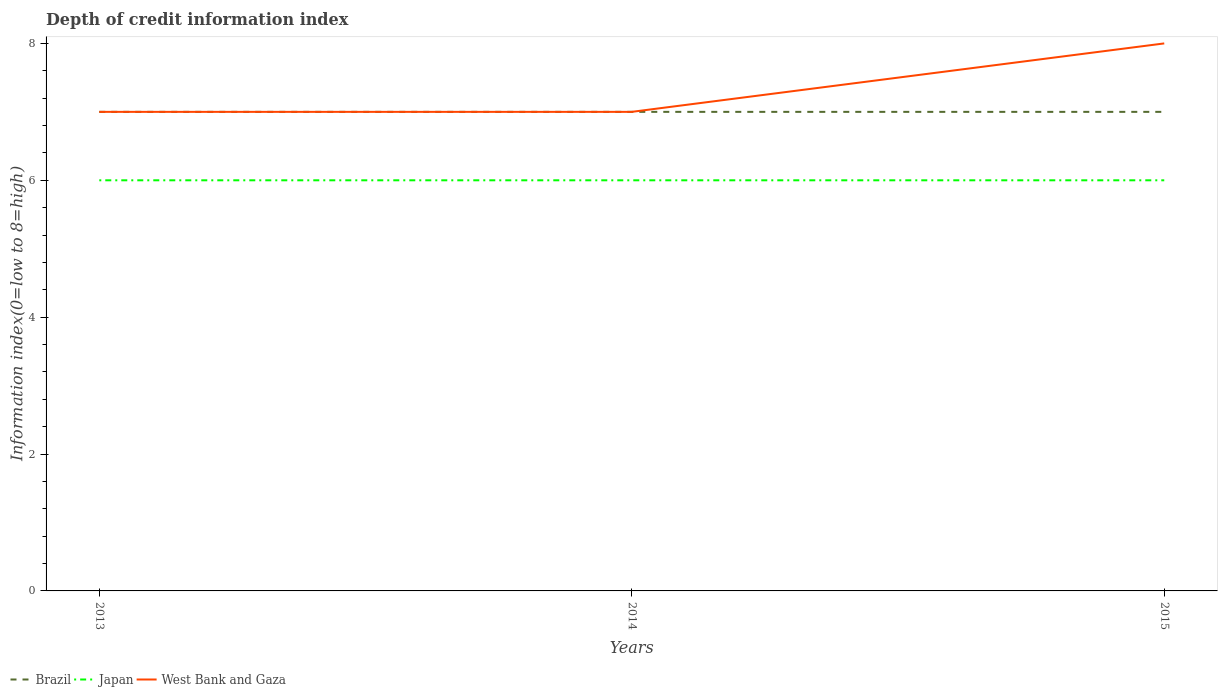How many different coloured lines are there?
Give a very brief answer. 3. Is the number of lines equal to the number of legend labels?
Offer a terse response. Yes. Across all years, what is the maximum information index in West Bank and Gaza?
Offer a very short reply. 7. What is the total information index in Brazil in the graph?
Your answer should be very brief. 0. What is the difference between the highest and the second highest information index in Brazil?
Give a very brief answer. 0. What is the difference between the highest and the lowest information index in Japan?
Your response must be concise. 0. How many lines are there?
Provide a succinct answer. 3. Does the graph contain any zero values?
Provide a succinct answer. No. Does the graph contain grids?
Keep it short and to the point. No. Where does the legend appear in the graph?
Your answer should be compact. Bottom left. How many legend labels are there?
Ensure brevity in your answer.  3. How are the legend labels stacked?
Offer a very short reply. Horizontal. What is the title of the graph?
Ensure brevity in your answer.  Depth of credit information index. What is the label or title of the X-axis?
Provide a short and direct response. Years. What is the label or title of the Y-axis?
Your answer should be compact. Information index(0=low to 8=high). What is the Information index(0=low to 8=high) of Japan in 2013?
Offer a terse response. 6. What is the Information index(0=low to 8=high) in West Bank and Gaza in 2013?
Ensure brevity in your answer.  7. What is the Information index(0=low to 8=high) of Brazil in 2014?
Provide a short and direct response. 7. What is the Information index(0=low to 8=high) in Japan in 2014?
Make the answer very short. 6. What is the Information index(0=low to 8=high) of West Bank and Gaza in 2014?
Your response must be concise. 7. What is the Information index(0=low to 8=high) in Japan in 2015?
Give a very brief answer. 6. What is the Information index(0=low to 8=high) in West Bank and Gaza in 2015?
Your answer should be very brief. 8. Across all years, what is the maximum Information index(0=low to 8=high) of Brazil?
Provide a short and direct response. 7. Across all years, what is the minimum Information index(0=low to 8=high) in Brazil?
Make the answer very short. 7. Across all years, what is the minimum Information index(0=low to 8=high) of Japan?
Make the answer very short. 6. What is the total Information index(0=low to 8=high) of Japan in the graph?
Your response must be concise. 18. What is the difference between the Information index(0=low to 8=high) of Brazil in 2013 and that in 2014?
Keep it short and to the point. 0. What is the difference between the Information index(0=low to 8=high) of Japan in 2013 and that in 2014?
Provide a succinct answer. 0. What is the difference between the Information index(0=low to 8=high) in West Bank and Gaza in 2013 and that in 2014?
Ensure brevity in your answer.  0. What is the difference between the Information index(0=low to 8=high) of West Bank and Gaza in 2014 and that in 2015?
Make the answer very short. -1. What is the difference between the Information index(0=low to 8=high) of Brazil in 2013 and the Information index(0=low to 8=high) of West Bank and Gaza in 2014?
Ensure brevity in your answer.  0. What is the difference between the Information index(0=low to 8=high) in Japan in 2013 and the Information index(0=low to 8=high) in West Bank and Gaza in 2015?
Give a very brief answer. -2. What is the average Information index(0=low to 8=high) of Brazil per year?
Offer a terse response. 7. What is the average Information index(0=low to 8=high) in Japan per year?
Ensure brevity in your answer.  6. What is the average Information index(0=low to 8=high) in West Bank and Gaza per year?
Make the answer very short. 7.33. In the year 2013, what is the difference between the Information index(0=low to 8=high) of Brazil and Information index(0=low to 8=high) of Japan?
Ensure brevity in your answer.  1. In the year 2013, what is the difference between the Information index(0=low to 8=high) in Brazil and Information index(0=low to 8=high) in West Bank and Gaza?
Your response must be concise. 0. In the year 2013, what is the difference between the Information index(0=low to 8=high) in Japan and Information index(0=low to 8=high) in West Bank and Gaza?
Give a very brief answer. -1. In the year 2014, what is the difference between the Information index(0=low to 8=high) of Brazil and Information index(0=low to 8=high) of West Bank and Gaza?
Provide a succinct answer. 0. What is the ratio of the Information index(0=low to 8=high) in Brazil in 2013 to that in 2014?
Your answer should be compact. 1. What is the ratio of the Information index(0=low to 8=high) in Japan in 2013 to that in 2014?
Make the answer very short. 1. What is the ratio of the Information index(0=low to 8=high) of Japan in 2013 to that in 2015?
Provide a succinct answer. 1. What is the ratio of the Information index(0=low to 8=high) in Brazil in 2014 to that in 2015?
Provide a succinct answer. 1. What is the ratio of the Information index(0=low to 8=high) in Japan in 2014 to that in 2015?
Give a very brief answer. 1. What is the difference between the highest and the second highest Information index(0=low to 8=high) in Brazil?
Ensure brevity in your answer.  0. What is the difference between the highest and the lowest Information index(0=low to 8=high) of Brazil?
Provide a succinct answer. 0. What is the difference between the highest and the lowest Information index(0=low to 8=high) of Japan?
Make the answer very short. 0. 